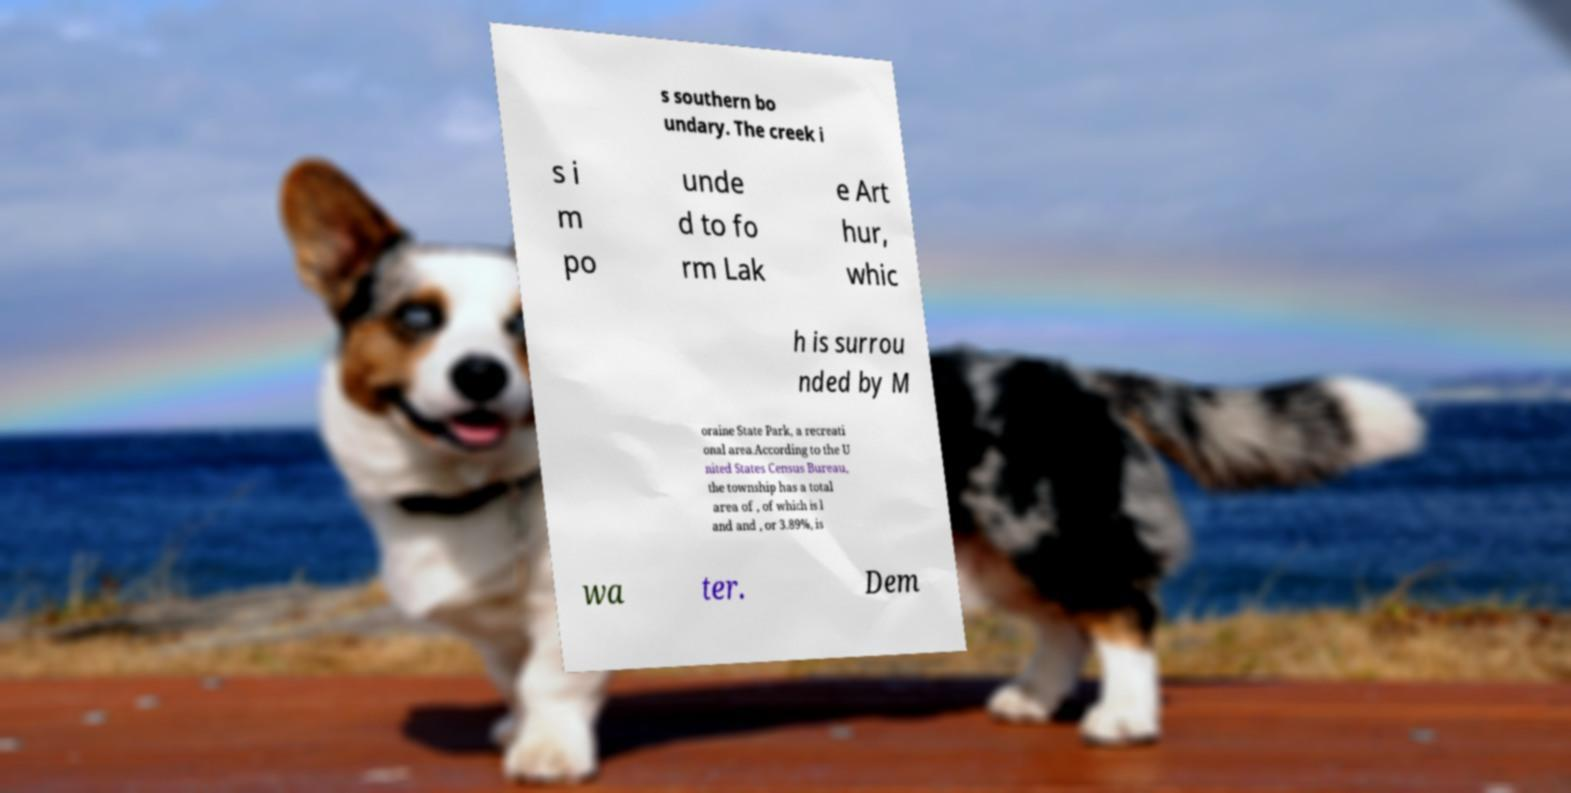For documentation purposes, I need the text within this image transcribed. Could you provide that? s southern bo undary. The creek i s i m po unde d to fo rm Lak e Art hur, whic h is surrou nded by M oraine State Park, a recreati onal area.According to the U nited States Census Bureau, the township has a total area of , of which is l and and , or 3.89%, is wa ter. Dem 